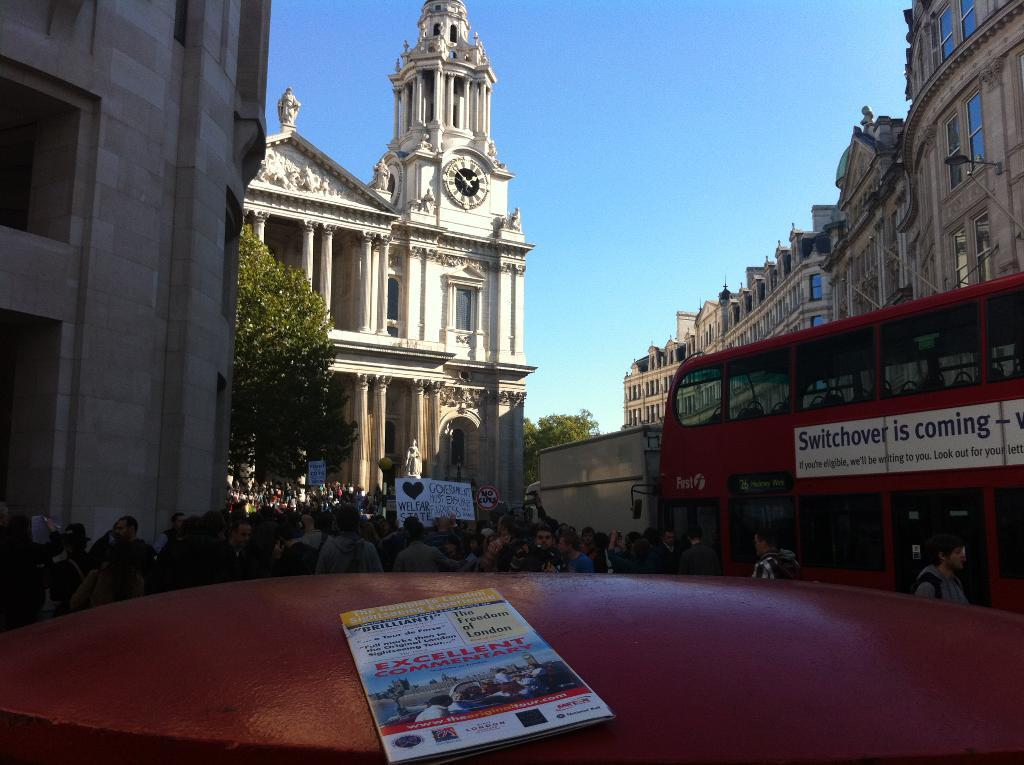What type of structures can be seen in the image? There are buildings in the image, including a clock tower. What else can be found in the image besides buildings? There are trees, the sky, persons, a motor vehicle, and a book placed on the wall in the image. What advice does the grandfather give to the persons in the image? There is no grandfather present in the image, so it is not possible to answer that question. 